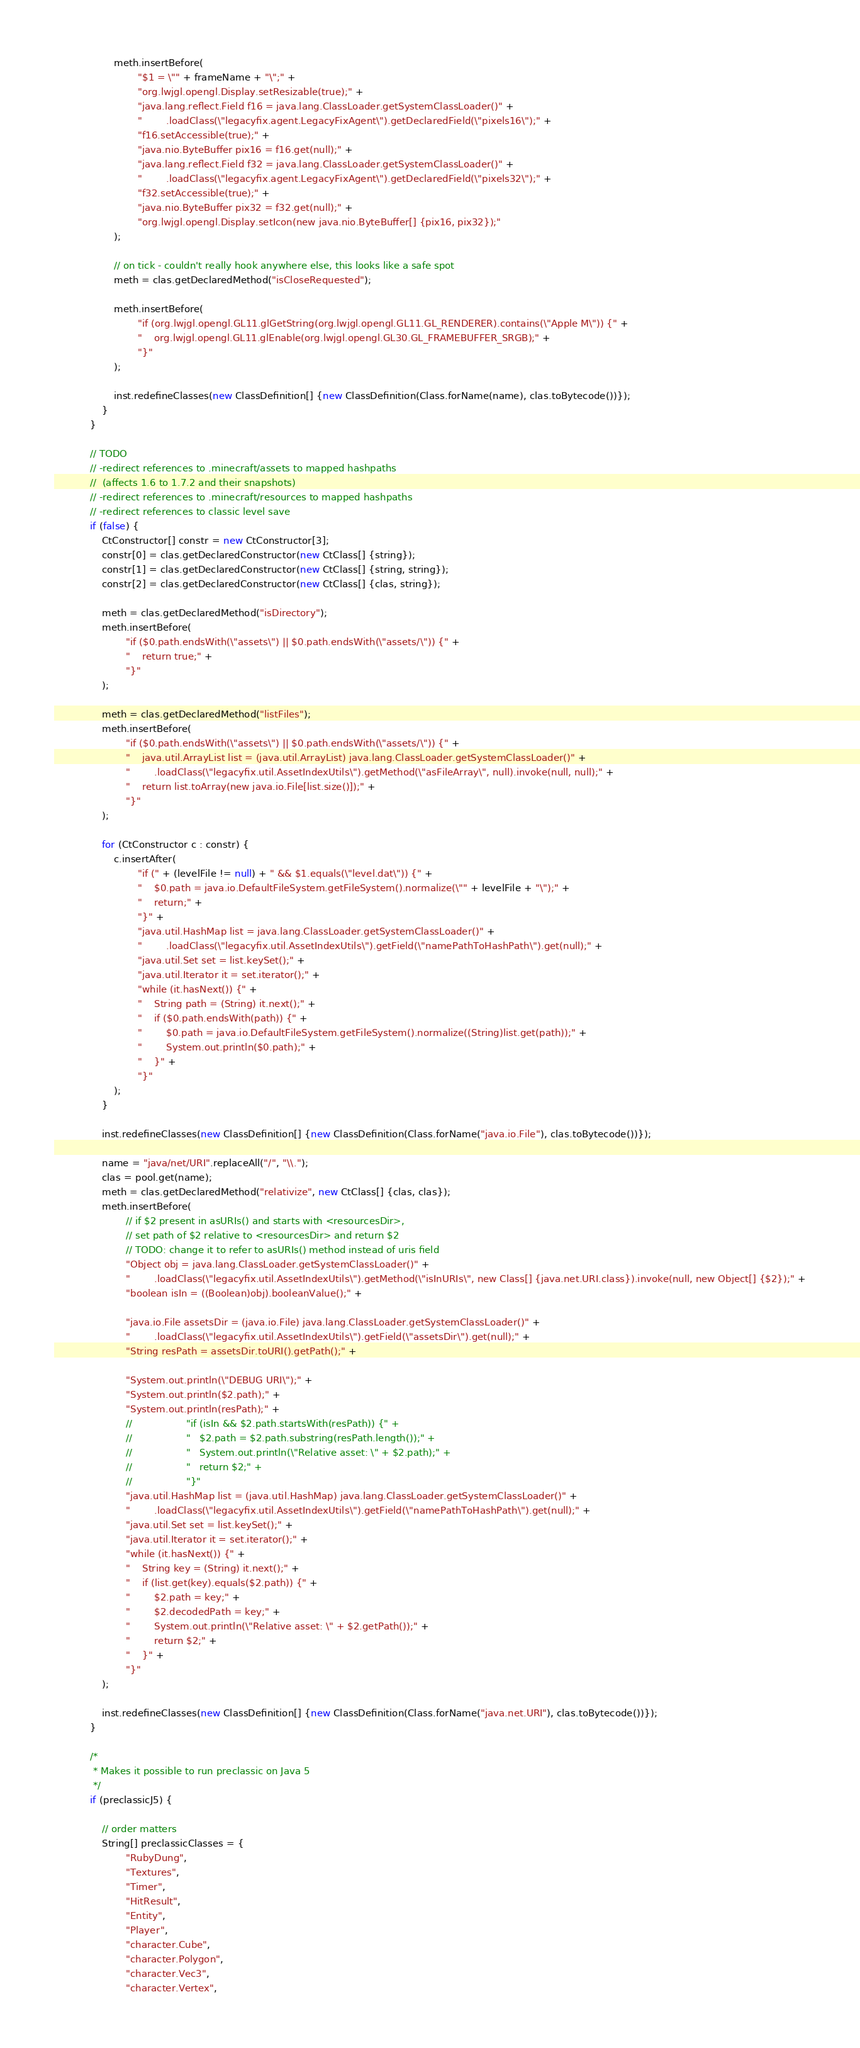<code> <loc_0><loc_0><loc_500><loc_500><_Java_>					meth.insertBefore(
							"$1 = \"" + frameName + "\";" +
							"org.lwjgl.opengl.Display.setResizable(true);" +
							"java.lang.reflect.Field f16 = java.lang.ClassLoader.getSystemClassLoader()" +
							"		.loadClass(\"legacyfix.agent.LegacyFixAgent\").getDeclaredField(\"pixels16\");" +
							"f16.setAccessible(true);" +
							"java.nio.ByteBuffer pix16 = f16.get(null);" +
							"java.lang.reflect.Field f32 = java.lang.ClassLoader.getSystemClassLoader()" +
							"		.loadClass(\"legacyfix.agent.LegacyFixAgent\").getDeclaredField(\"pixels32\");" +
							"f32.setAccessible(true);" +
							"java.nio.ByteBuffer pix32 = f32.get(null);" +
							"org.lwjgl.opengl.Display.setIcon(new java.nio.ByteBuffer[] {pix16, pix32});"
					);

					// on tick - couldn't really hook anywhere else, this looks like a safe spot
					meth = clas.getDeclaredMethod("isCloseRequested");

					meth.insertBefore(
							"if (org.lwjgl.opengl.GL11.glGetString(org.lwjgl.opengl.GL11.GL_RENDERER).contains(\"Apple M\")) {" + 
							"	org.lwjgl.opengl.GL11.glEnable(org.lwjgl.opengl.GL30.GL_FRAMEBUFFER_SRGB);" +
							"}"
					);

					inst.redefineClasses(new ClassDefinition[] {new ClassDefinition(Class.forName(name), clas.toBytecode())});
				}
			}

			// TODO 
			// -redirect references to .minecraft/assets to mapped hashpaths
			//  (affects 1.6 to 1.7.2 and their snapshots)
			// -redirect references to .minecraft/resources to mapped hashpaths
			// -redirect references to classic level save
			if (false) {
				CtConstructor[] constr = new CtConstructor[3];
				constr[0] = clas.getDeclaredConstructor(new CtClass[] {string});
				constr[1] = clas.getDeclaredConstructor(new CtClass[] {string, string});
				constr[2] = clas.getDeclaredConstructor(new CtClass[] {clas, string});

				meth = clas.getDeclaredMethod("isDirectory");
				meth.insertBefore(
						"if ($0.path.endsWith(\"assets\") || $0.path.endsWith(\"assets/\")) {" +
						"	return true;" +
						"}"
				);

				meth = clas.getDeclaredMethod("listFiles");
				meth.insertBefore(
						"if ($0.path.endsWith(\"assets\") || $0.path.endsWith(\"assets/\")) {" +
						"	java.util.ArrayList list = (java.util.ArrayList) java.lang.ClassLoader.getSystemClassLoader()" +
						"		.loadClass(\"legacyfix.util.AssetIndexUtils\").getMethod(\"asFileArray\", null).invoke(null, null);" +
						"	return list.toArray(new java.io.File[list.size()]);" +
						"}"
				);

				for (CtConstructor c : constr) {
					c.insertAfter(
							"if (" + (levelFile != null) + " && $1.equals(\"level.dat\")) {" +
							"	$0.path = java.io.DefaultFileSystem.getFileSystem().normalize(\"" + levelFile + "\");" +
							"	return;" +
							"}" +
							"java.util.HashMap list = java.lang.ClassLoader.getSystemClassLoader()" +
							"		.loadClass(\"legacyfix.util.AssetIndexUtils\").getField(\"namePathToHashPath\").get(null);" +
							"java.util.Set set = list.keySet();" +
							"java.util.Iterator it = set.iterator();" +
							"while (it.hasNext()) {" +
							"	String path = (String) it.next();" +
							"	if ($0.path.endsWith(path)) {" +
							"		$0.path = java.io.DefaultFileSystem.getFileSystem().normalize((String)list.get(path));" +
							"		System.out.println($0.path);" +
							"	}" +
							"}"
					);
				}

				inst.redefineClasses(new ClassDefinition[] {new ClassDefinition(Class.forName("java.io.File"), clas.toBytecode())});

				name = "java/net/URI".replaceAll("/", "\\.");
				clas = pool.get(name);
				meth = clas.getDeclaredMethod("relativize", new CtClass[] {clas, clas});
				meth.insertBefore(
						// if $2 present in asURIs() and starts with <resourcesDir>,
						// set path of $2 relative to <resourcesDir> and return $2
						// TODO: change it to refer to asURIs() method instead of uris field
						"Object obj = java.lang.ClassLoader.getSystemClassLoader()" +
						"		.loadClass(\"legacyfix.util.AssetIndexUtils\").getMethod(\"isInURIs\", new Class[] {java.net.URI.class}).invoke(null, new Object[] {$2});" +
						"boolean isIn = ((Boolean)obj).booleanValue();" +

						"java.io.File assetsDir = (java.io.File) java.lang.ClassLoader.getSystemClassLoader()" +
						"		.loadClass(\"legacyfix.util.AssetIndexUtils\").getField(\"assetsDir\").get(null);" +
						"String resPath = assetsDir.toURI().getPath();" +

						"System.out.println(\"DEBUG URI\");" +
						"System.out.println($2.path);" +
						"System.out.println(resPath);" +
						//					"if (isIn && $2.path.startsWith(resPath)) {" +
						//					"	$2.path = $2.path.substring(resPath.length());" +
						//					"	System.out.println(\"Relative asset: \" + $2.path);" +
						//					"	return $2;" +
						//					"}"
						"java.util.HashMap list = (java.util.HashMap) java.lang.ClassLoader.getSystemClassLoader()" +
						"		.loadClass(\"legacyfix.util.AssetIndexUtils\").getField(\"namePathToHashPath\").get(null);" +
						"java.util.Set set = list.keySet();" +
						"java.util.Iterator it = set.iterator();" +
						"while (it.hasNext()) {" +
						"	String key = (String) it.next();" +
						"	if (list.get(key).equals($2.path)) {" +
						"		$2.path = key;" +
						"		$2.decodedPath = key;" +
						"		System.out.println(\"Relative asset: \" + $2.getPath());" +
						"		return $2;" +
						"	}" +
						"}"
				);

				inst.redefineClasses(new ClassDefinition[] {new ClassDefinition(Class.forName("java.net.URI"), clas.toBytecode())});
			}

			/*
			 * Makes it possible to run preclassic on Java 5
			 */
			if (preclassicJ5) {

				// order matters
				String[] preclassicClasses = {
						"RubyDung",
						"Textures",
						"Timer",
						"HitResult",
						"Entity",
						"Player",
						"character.Cube",
						"character.Polygon",
						"character.Vec3",
						"character.Vertex",</code> 